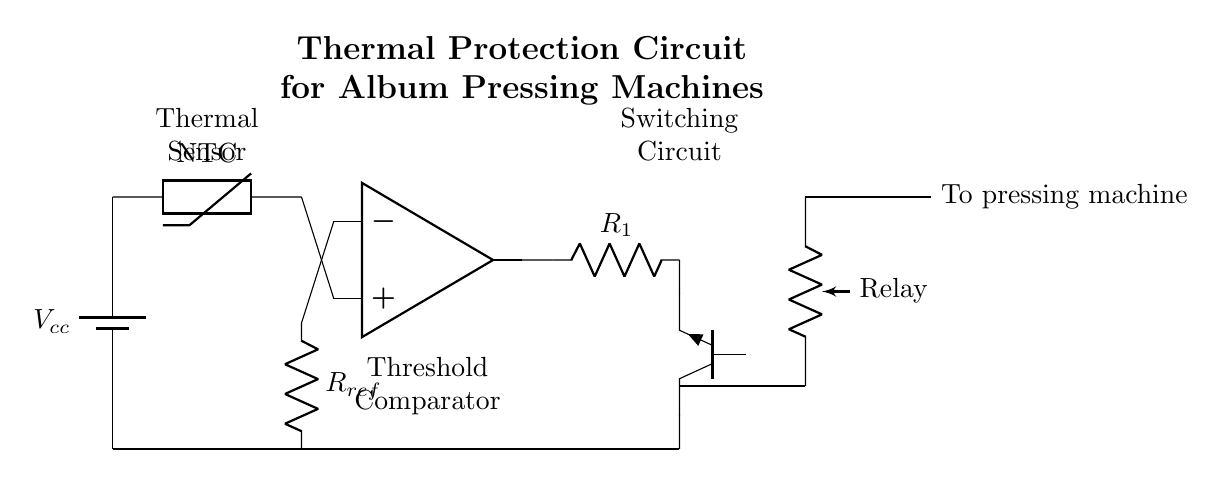What type of sensor is used in this circuit? The circuit diagram includes a thermistor, specifically a negative temperature coefficient (NTC) thermistor, which changes resistance with temperature.
Answer: NTC thermistor What does the comparator do in this circuit? The comparator compares the voltage from the thermistor with a reference voltage set by the resistor connected to it, enabling it to determine if the temperature exceeds a certain threshold.
Answer: Determines temperature threshold What component acts as a switch in this circuit? The diagram shows a transistor, specifically an NPN type, which functions as a switch to control the relay based on the comparator's output.
Answer: Transistor How many resistors are present in this circuit? There are two resistors visible in the circuit: one is the reference resistor connected to the comparator, and the other is the resistor in series with the transistor.
Answer: Two resistors What happens when the temperature exceeds the threshold? The comparator output will signal the transistor to turn on, activating the relay, which will then cut off power to the pressing machine to prevent overheating.
Answer: Power is cut off What is the purpose of the relay in this circuit? The relay acts as a protective device that disconnects the pressing machine from the power supply when the current is activated by the switch.
Answer: Disconnects power What does the voltage label V cc indicate? The V cc label represents the power supply voltage in the circuit, which is typically connected to the source of the entire system.
Answer: Power supply voltage 